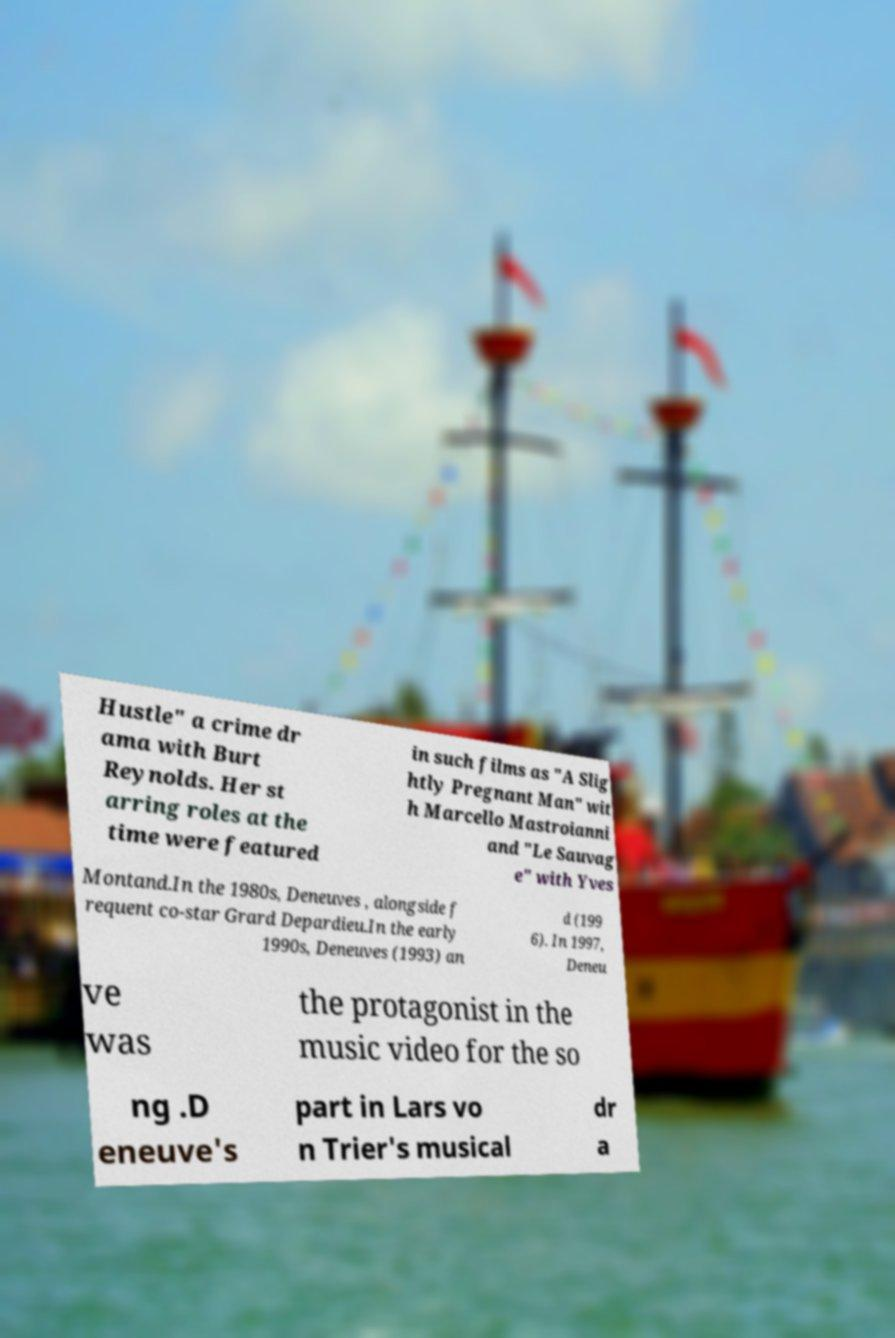Could you extract and type out the text from this image? Hustle" a crime dr ama with Burt Reynolds. Her st arring roles at the time were featured in such films as "A Slig htly Pregnant Man" wit h Marcello Mastroianni and "Le Sauvag e" with Yves Montand.In the 1980s, Deneuves , alongside f requent co-star Grard Depardieu.In the early 1990s, Deneuves (1993) an d (199 6). In 1997, Deneu ve was the protagonist in the music video for the so ng .D eneuve's part in Lars vo n Trier's musical dr a 